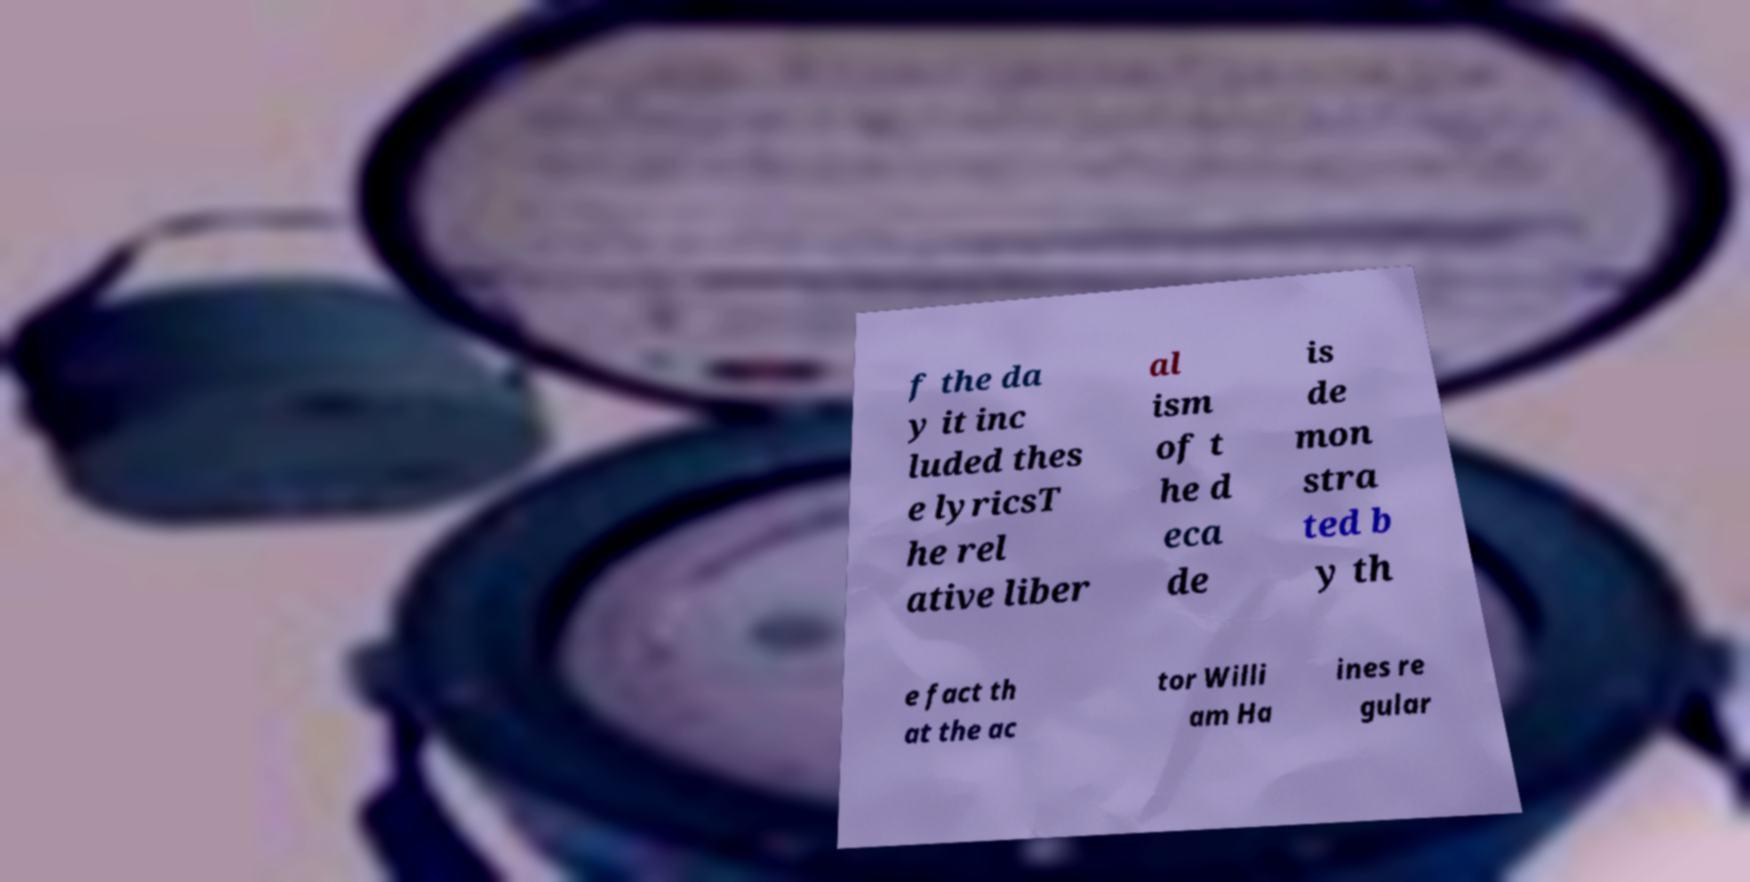I need the written content from this picture converted into text. Can you do that? f the da y it inc luded thes e lyricsT he rel ative liber al ism of t he d eca de is de mon stra ted b y th e fact th at the ac tor Willi am Ha ines re gular 